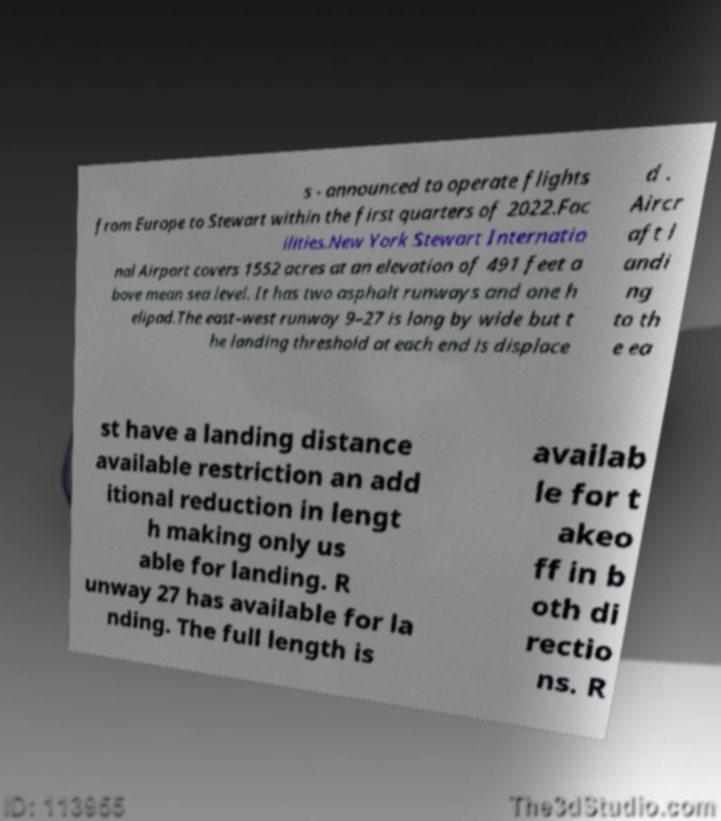Could you assist in decoding the text presented in this image and type it out clearly? s - announced to operate flights from Europe to Stewart within the first quarters of 2022.Fac ilities.New York Stewart Internatio nal Airport covers 1552 acres at an elevation of 491 feet a bove mean sea level. It has two asphalt runways and one h elipad.The east–west runway 9–27 is long by wide but t he landing threshold at each end is displace d . Aircr aft l andi ng to th e ea st have a landing distance available restriction an add itional reduction in lengt h making only us able for landing. R unway 27 has available for la nding. The full length is availab le for t akeo ff in b oth di rectio ns. R 